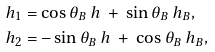<formula> <loc_0><loc_0><loc_500><loc_500>h _ { 1 } & = \cos \theta _ { B } \ h \ + \ \sin \theta _ { B } \ h _ { B } , \\ h _ { 2 } & = - \sin \theta _ { B } \ h \ + \ \cos \theta _ { B } \ h _ { B } ,</formula> 